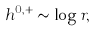<formula> <loc_0><loc_0><loc_500><loc_500>h ^ { 0 , + } \sim \log r ,</formula> 